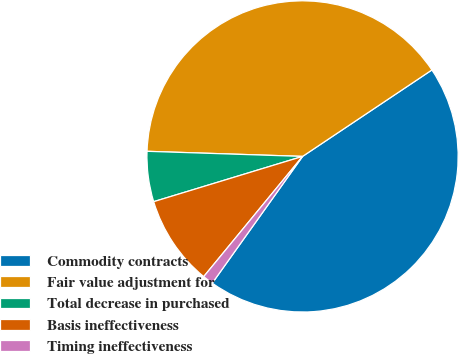<chart> <loc_0><loc_0><loc_500><loc_500><pie_chart><fcel>Commodity contracts<fcel>Fair value adjustment for<fcel>Total decrease in purchased<fcel>Basis ineffectiveness<fcel>Timing ineffectiveness<nl><fcel>44.23%<fcel>40.1%<fcel>5.22%<fcel>9.35%<fcel>1.1%<nl></chart> 